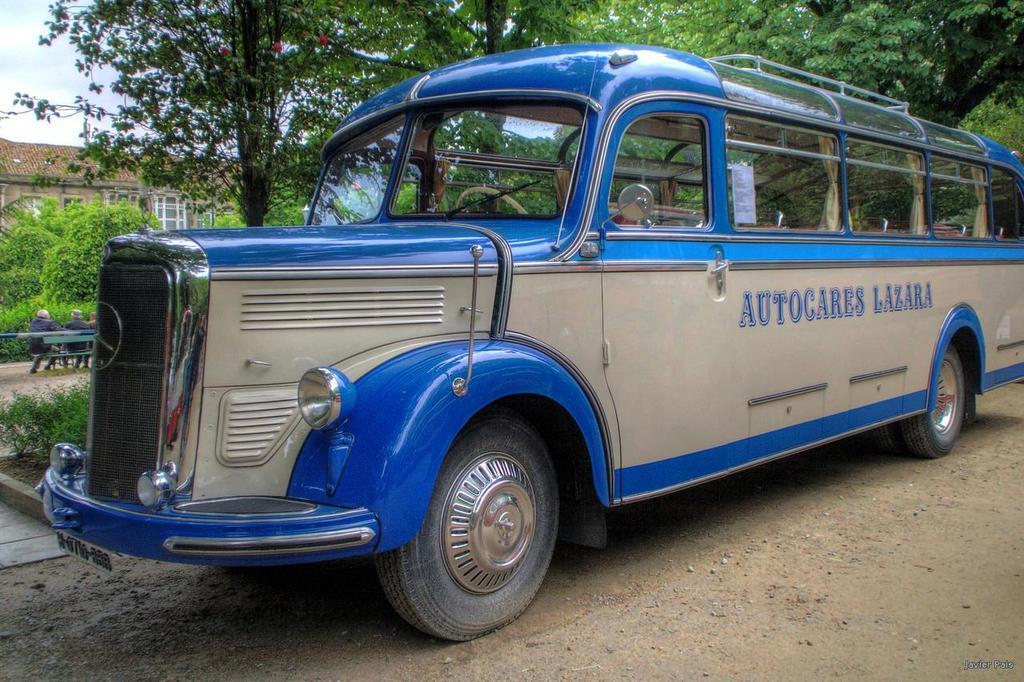Could you give a brief overview of what you see in this image? In this image, we can see a bus on the road and in the background, there are trees, buildings and we can see some people sitting on the bench. 